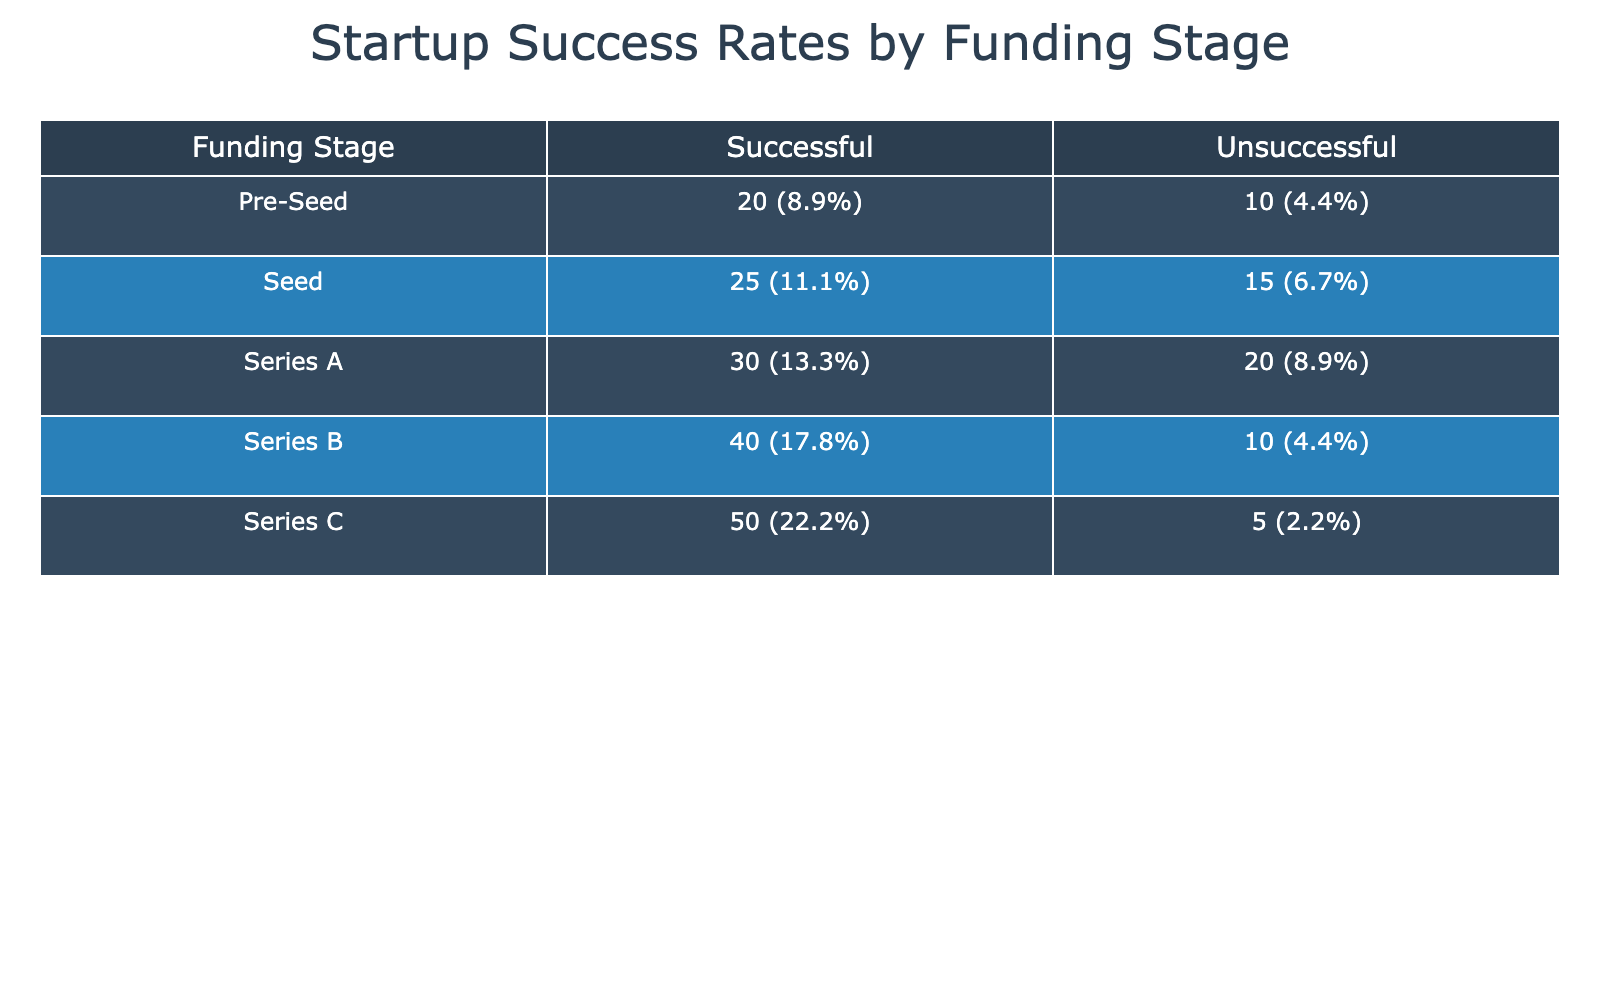What is the total count of successful startups across all funding stages? To find the total count of successful startups, I will sum the 'Successful' counts across each funding stage: 25 (Seed) + 30 (Series A) + 40 (Series B) + 50 (Series C) + 20 (Pre-Seed) = 165.
Answer: 165 How many unsuccessful startups were funded during the Series A stage? Looking at the Series A row, the count of unsuccessful startups is clearly stated: 20.
Answer: 20 What is the success rate (percentage) for Series B startups? The total count of Series B startups is 40 (Successful) + 10 (Unsuccessful) = 50. The success rate is calculated as (Successful count / Total count) * 100, which is (40 / 50) * 100 = 80%.
Answer: 80% Are there more successful startups in the Seed stage than the Pre-Seed stage? Comparing the counts, Seed has 25 successful startups and Pre-Seed has 20 successful startups. Since 25 is greater than 20, yes, there are more successful startups in Seed.
Answer: Yes What is the difference in the count of successful startups between Series C and Series B? The successful startup count for Series C is 50 and for Series B is 40. The difference is calculated as 50 - 40 = 10.
Answer: 10 How many total startups were evaluated in the Seed funding stage? The total count for Seed is found by adding both Successful (25) and Unsuccessful (15) counts: 25 + 15 = 40.
Answer: 40 Do more startups succeed in the Pre-Seed stage than in the Series B stage? Successful startups in Pre-Seed are 20, and in Series B they are 40. Since 20 is less than 40, the statement is false.
Answer: No What is the average success rate of all funding stages combined? Total successful counts = 165 and total counts across all funding stages = 25 + 15 + 30 + 20 + 40 + 10 + 50 + 5 + 20 + 10 = 225. The average success rate is then calculated as (Total Successful / Total Count) * 100 = (165 / 225) * 100 ≈ 73.33%.
Answer: 73.33% 